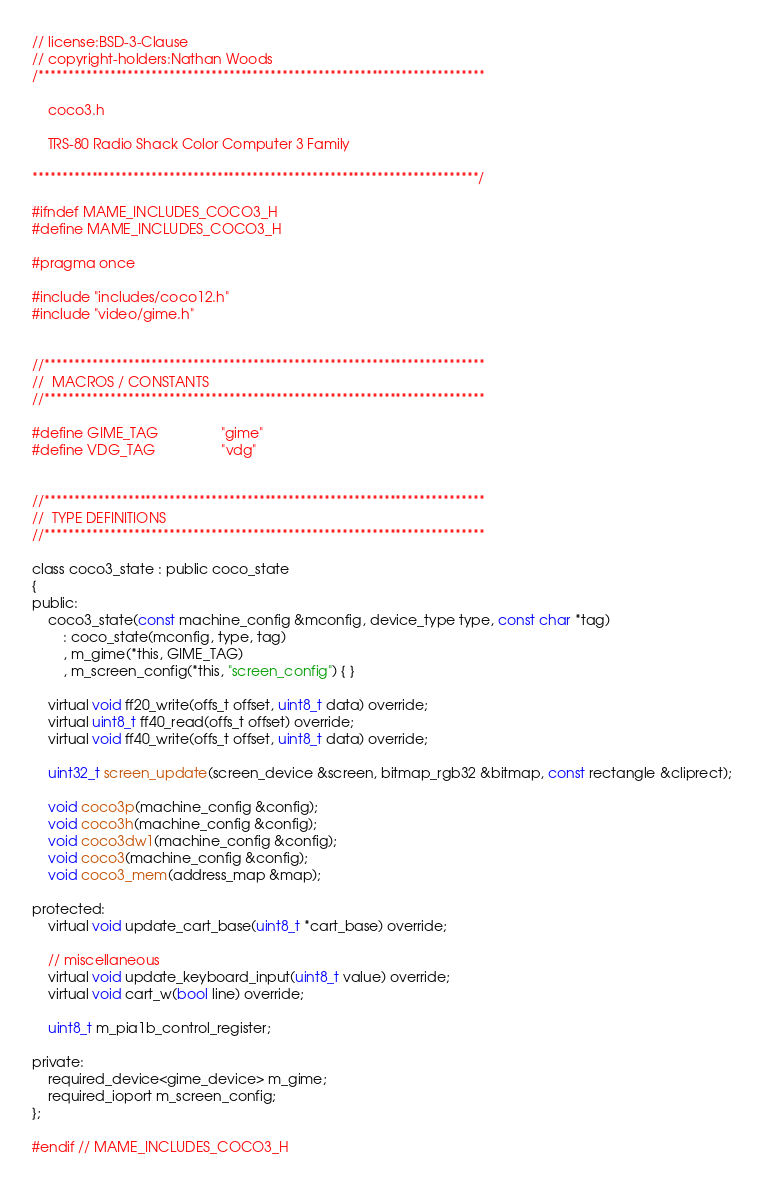Convert code to text. <code><loc_0><loc_0><loc_500><loc_500><_C_>// license:BSD-3-Clause
// copyright-holders:Nathan Woods
/***************************************************************************

    coco3.h

    TRS-80 Radio Shack Color Computer 3 Family

***************************************************************************/

#ifndef MAME_INCLUDES_COCO3_H
#define MAME_INCLUDES_COCO3_H

#pragma once

#include "includes/coco12.h"
#include "video/gime.h"


//**************************************************************************
//  MACROS / CONSTANTS
//**************************************************************************

#define GIME_TAG                "gime"
#define VDG_TAG                 "vdg"


//**************************************************************************
//  TYPE DEFINITIONS
//**************************************************************************

class coco3_state : public coco_state
{
public:
	coco3_state(const machine_config &mconfig, device_type type, const char *tag)
		: coco_state(mconfig, type, tag)
		, m_gime(*this, GIME_TAG)
		, m_screen_config(*this, "screen_config") { }

	virtual void ff20_write(offs_t offset, uint8_t data) override;
	virtual uint8_t ff40_read(offs_t offset) override;
	virtual void ff40_write(offs_t offset, uint8_t data) override;

	uint32_t screen_update(screen_device &screen, bitmap_rgb32 &bitmap, const rectangle &cliprect);

	void coco3p(machine_config &config);
	void coco3h(machine_config &config);
	void coco3dw1(machine_config &config);
	void coco3(machine_config &config);
	void coco3_mem(address_map &map);

protected:
	virtual void update_cart_base(uint8_t *cart_base) override;

	// miscellaneous
	virtual void update_keyboard_input(uint8_t value) override;
	virtual void cart_w(bool line) override;

	uint8_t m_pia1b_control_register;

private:
	required_device<gime_device> m_gime;
	required_ioport m_screen_config;
};

#endif // MAME_INCLUDES_COCO3_H
</code> 